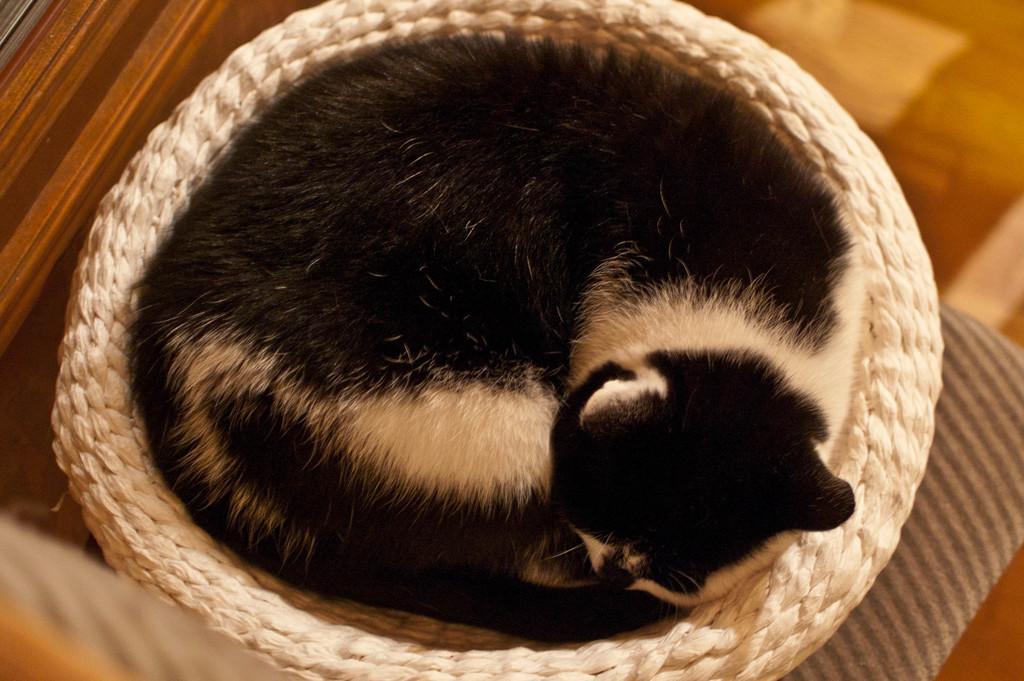Can you describe this image briefly? In this image I can see an animal visible on basket and basket is kept on floor. 